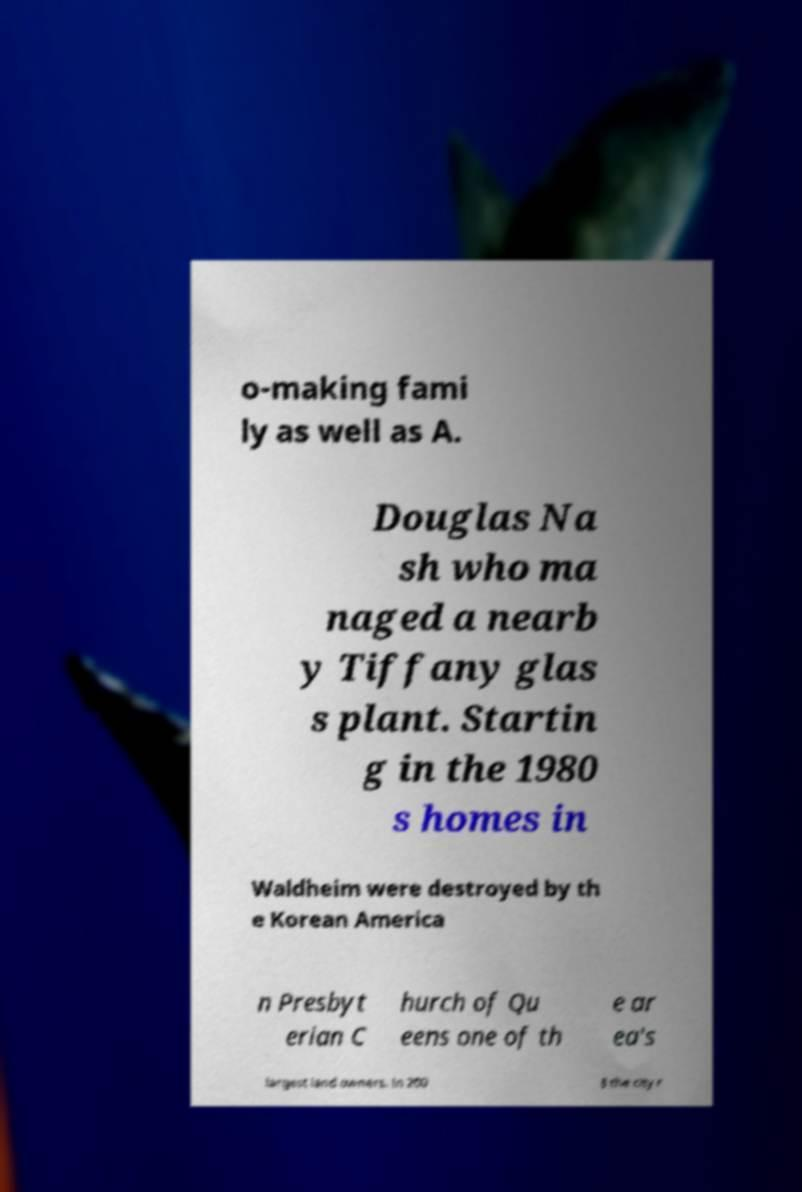Please read and relay the text visible in this image. What does it say? o-making fami ly as well as A. Douglas Na sh who ma naged a nearb y Tiffany glas s plant. Startin g in the 1980 s homes in Waldheim were destroyed by th e Korean America n Presbyt erian C hurch of Qu eens one of th e ar ea's largest land owners. In 200 8 the city r 